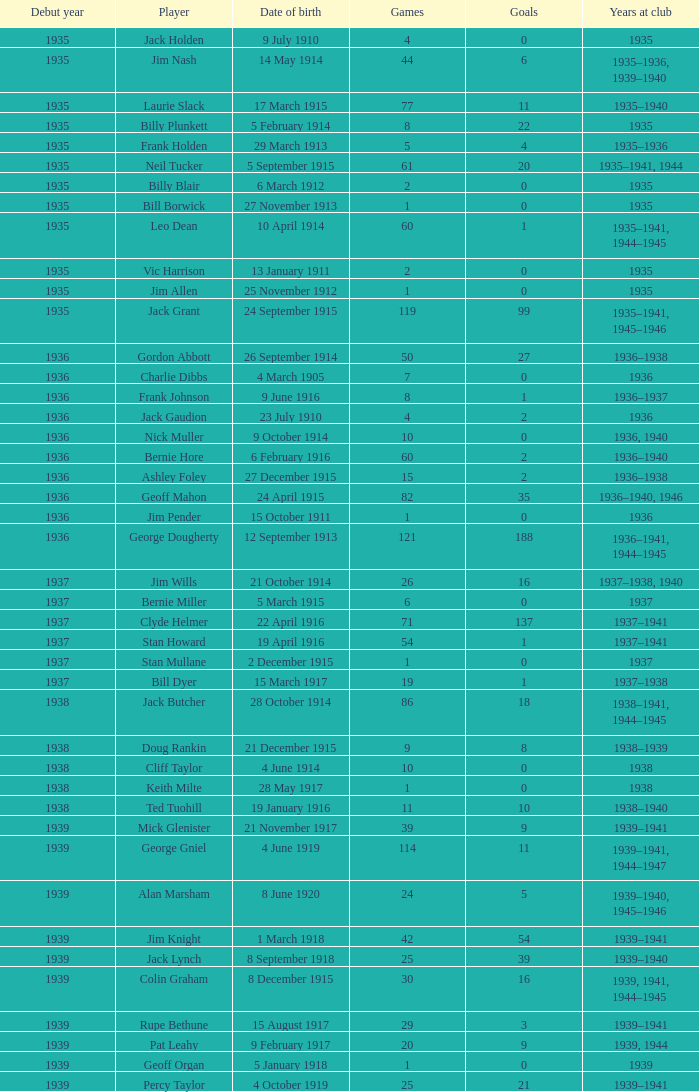How many games had 22 goals before 1935? None. Would you mind parsing the complete table? {'header': ['Debut year', 'Player', 'Date of birth', 'Games', 'Goals', 'Years at club'], 'rows': [['1935', 'Jack Holden', '9 July 1910', '4', '0', '1935'], ['1935', 'Jim Nash', '14 May 1914', '44', '6', '1935–1936, 1939–1940'], ['1935', 'Laurie Slack', '17 March 1915', '77', '11', '1935–1940'], ['1935', 'Billy Plunkett', '5 February 1914', '8', '22', '1935'], ['1935', 'Frank Holden', '29 March 1913', '5', '4', '1935–1936'], ['1935', 'Neil Tucker', '5 September 1915', '61', '20', '1935–1941, 1944'], ['1935', 'Billy Blair', '6 March 1912', '2', '0', '1935'], ['1935', 'Bill Borwick', '27 November 1913', '1', '0', '1935'], ['1935', 'Leo Dean', '10 April 1914', '60', '1', '1935–1941, 1944–1945'], ['1935', 'Vic Harrison', '13 January 1911', '2', '0', '1935'], ['1935', 'Jim Allen', '25 November 1912', '1', '0', '1935'], ['1935', 'Jack Grant', '24 September 1915', '119', '99', '1935–1941, 1945–1946'], ['1936', 'Gordon Abbott', '26 September 1914', '50', '27', '1936–1938'], ['1936', 'Charlie Dibbs', '4 March 1905', '7', '0', '1936'], ['1936', 'Frank Johnson', '9 June 1916', '8', '1', '1936–1937'], ['1936', 'Jack Gaudion', '23 July 1910', '4', '2', '1936'], ['1936', 'Nick Muller', '9 October 1914', '10', '0', '1936, 1940'], ['1936', 'Bernie Hore', '6 February 1916', '60', '2', '1936–1940'], ['1936', 'Ashley Foley', '27 December 1915', '15', '2', '1936–1938'], ['1936', 'Geoff Mahon', '24 April 1915', '82', '35', '1936–1940, 1946'], ['1936', 'Jim Pender', '15 October 1911', '1', '0', '1936'], ['1936', 'George Dougherty', '12 September 1913', '121', '188', '1936–1941, 1944–1945'], ['1937', 'Jim Wills', '21 October 1914', '26', '16', '1937–1938, 1940'], ['1937', 'Bernie Miller', '5 March 1915', '6', '0', '1937'], ['1937', 'Clyde Helmer', '22 April 1916', '71', '137', '1937–1941'], ['1937', 'Stan Howard', '19 April 1916', '54', '1', '1937–1941'], ['1937', 'Stan Mullane', '2 December 1915', '1', '0', '1937'], ['1937', 'Bill Dyer', '15 March 1917', '19', '1', '1937–1938'], ['1938', 'Jack Butcher', '28 October 1914', '86', '18', '1938–1941, 1944–1945'], ['1938', 'Doug Rankin', '21 December 1915', '9', '8', '1938–1939'], ['1938', 'Cliff Taylor', '4 June 1914', '10', '0', '1938'], ['1938', 'Keith Milte', '28 May 1917', '1', '0', '1938'], ['1938', 'Ted Tuohill', '19 January 1916', '11', '10', '1938–1940'], ['1939', 'Mick Glenister', '21 November 1917', '39', '9', '1939–1941'], ['1939', 'George Gniel', '4 June 1919', '114', '11', '1939–1941, 1944–1947'], ['1939', 'Alan Marsham', '8 June 1920', '24', '5', '1939–1940, 1945–1946'], ['1939', 'Jim Knight', '1 March 1918', '42', '54', '1939–1941'], ['1939', 'Jack Lynch', '8 September 1918', '25', '39', '1939–1940'], ['1939', 'Colin Graham', '8 December 1915', '30', '16', '1939, 1941, 1944–1945'], ['1939', 'Rupe Bethune', '15 August 1917', '29', '3', '1939–1941'], ['1939', 'Pat Leahy', '9 February 1917', '20', '9', '1939, 1944'], ['1939', 'Geoff Organ', '5 January 1918', '1', '0', '1939'], ['1939', 'Percy Taylor', '4 October 1919', '25', '21', '1939–1941']]} 